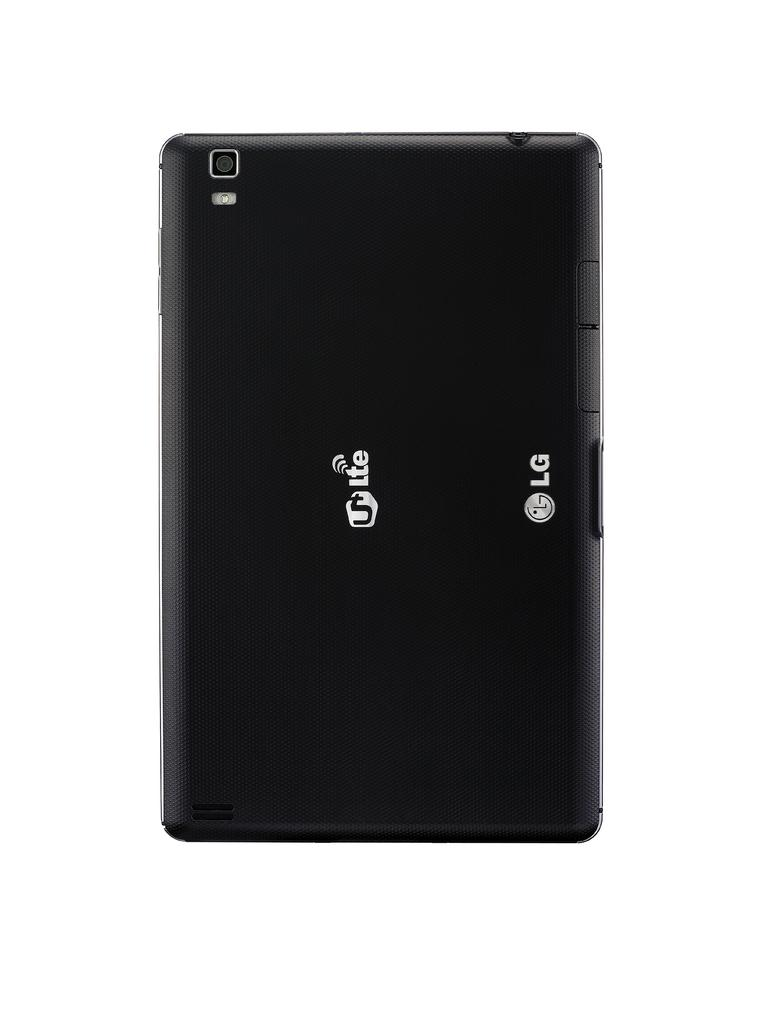<image>
Summarize the visual content of the image. A black tablet from LG brand and the model U Lte written on the back 